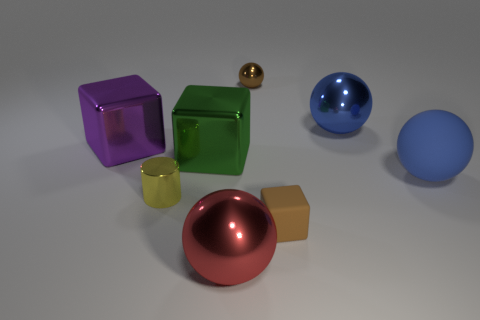Is the small shiny ball the same color as the matte cube?
Your answer should be very brief. Yes. Is there any other thing of the same color as the matte block?
Provide a succinct answer. Yes. Does the big blue rubber object have the same shape as the big blue thing that is behind the large blue matte ball?
Your response must be concise. Yes. What is the size of the blue rubber sphere?
Keep it short and to the point. Large. Are there fewer blue balls that are on the left side of the small brown block than small brown objects?
Offer a very short reply. Yes. What number of shiny cylinders are the same size as the brown matte object?
Provide a succinct answer. 1. What is the shape of the metallic thing that is the same color as the rubber cube?
Ensure brevity in your answer.  Sphere. There is a small metal object behind the big blue metal sphere; is it the same color as the large ball behind the rubber ball?
Your answer should be compact. No. There is a large green metallic cube; how many big shiny objects are behind it?
Give a very brief answer. 2. What is the size of the metallic thing that is the same color as the small block?
Your response must be concise. Small. 